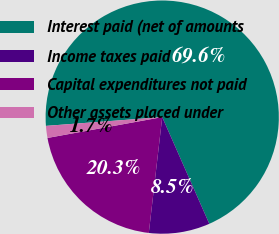Convert chart to OTSL. <chart><loc_0><loc_0><loc_500><loc_500><pie_chart><fcel>Interest paid (net of amounts<fcel>Income taxes paid<fcel>Capital expenditures not paid<fcel>Other assets placed under<nl><fcel>69.58%<fcel>8.45%<fcel>20.3%<fcel>1.66%<nl></chart> 